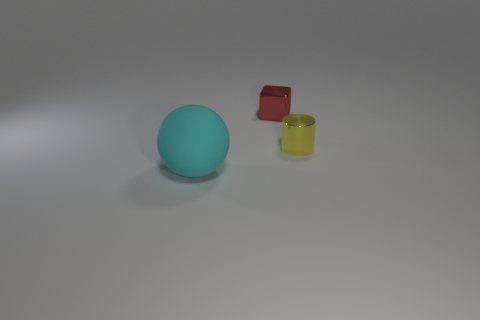Add 2 small metal cubes. How many objects exist? 5 Subtract 1 cubes. How many cubes are left? 0 Subtract all yellow cubes. Subtract all green cylinders. How many cubes are left? 1 Subtract all red blocks. Subtract all small shiny cubes. How many objects are left? 1 Add 3 cyan things. How many cyan things are left? 4 Add 2 red rubber cubes. How many red rubber cubes exist? 2 Subtract 0 brown cubes. How many objects are left? 3 Subtract all spheres. How many objects are left? 2 